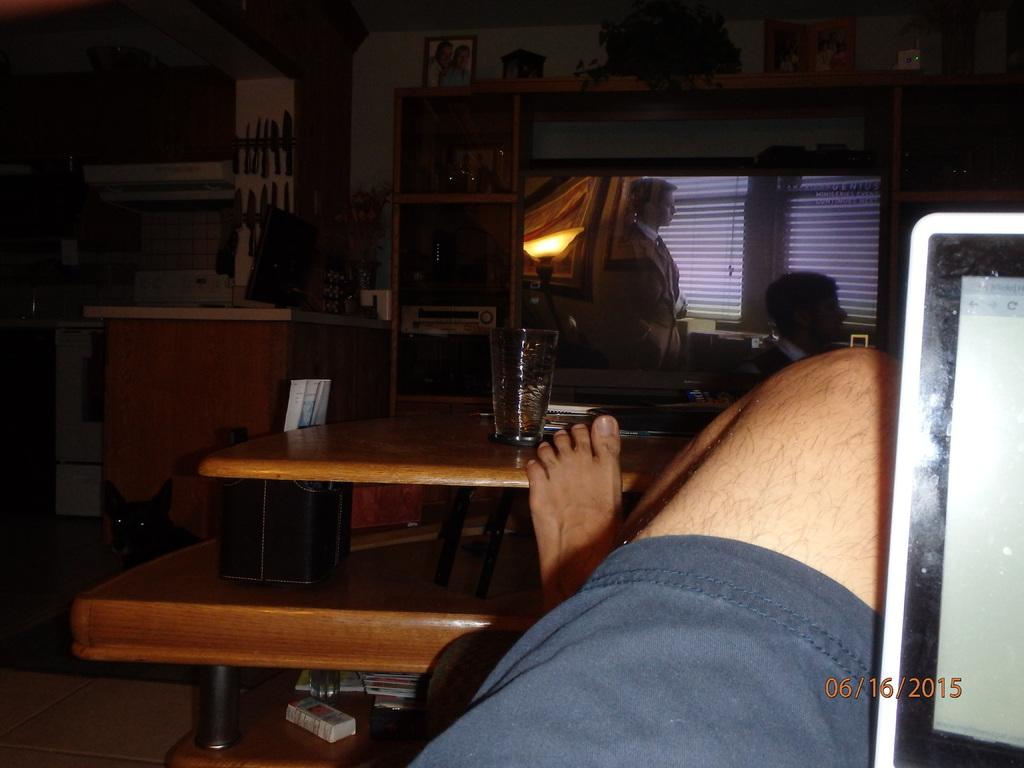Who is the main subject in the image? There is a boy in the image. What is the boy doing in the image? The boy is placing his leg on the table. What electronic device is at the center of the image? There is a television in the image, and it is at the center. What other electronic device is visible in the image? There is a laptop in the image, and it is at the right side. What type of scissors can be seen in the image? There are no scissors present in the image. What is the boy doing in the nation in the image? The image does not depict a nation, and the boy's action is already described as placing his leg on the table. 